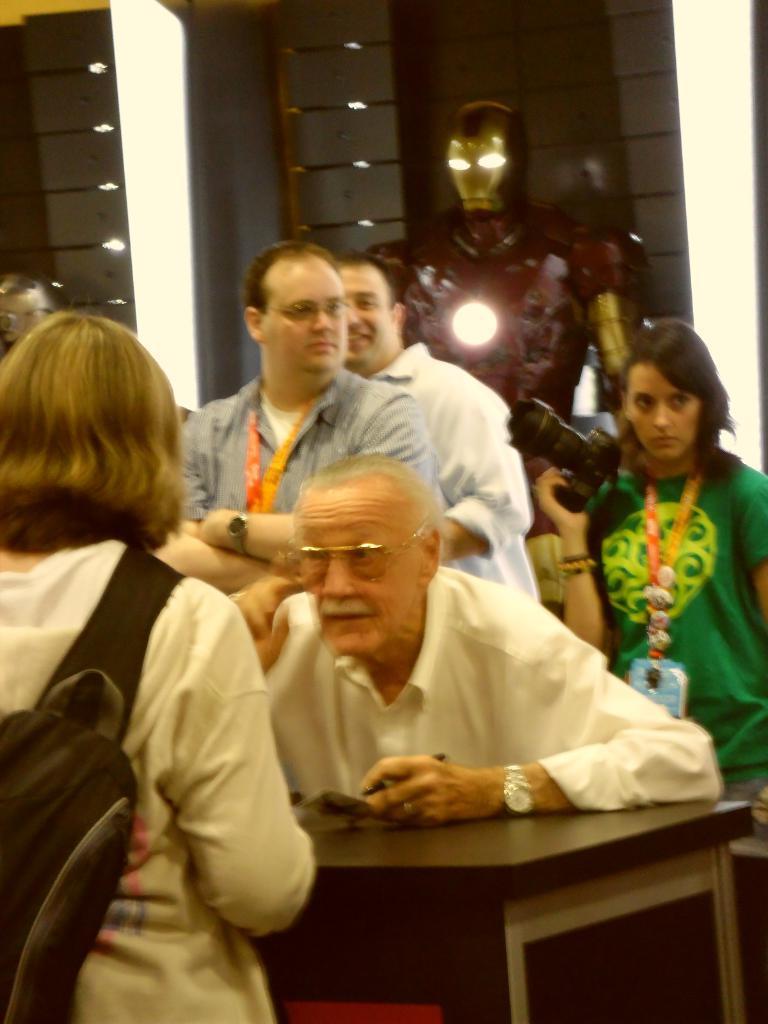How would you summarize this image in a sentence or two? In this picture we can see a group of people where one man wore spectacle, watch sitting and talking to the woman where she is carrying bag and at back of him we can see some persons and woman holding camera with her hands and in background we can see robot, lights. 